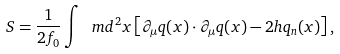<formula> <loc_0><loc_0><loc_500><loc_500>S = \frac { 1 } { 2 f _ { 0 } } \int \ m d ^ { 2 } x \left [ \partial _ { \mu } q ( x ) \cdot \partial _ { \mu } q ( x ) - 2 h q _ { n } ( x ) \right ] ,</formula> 